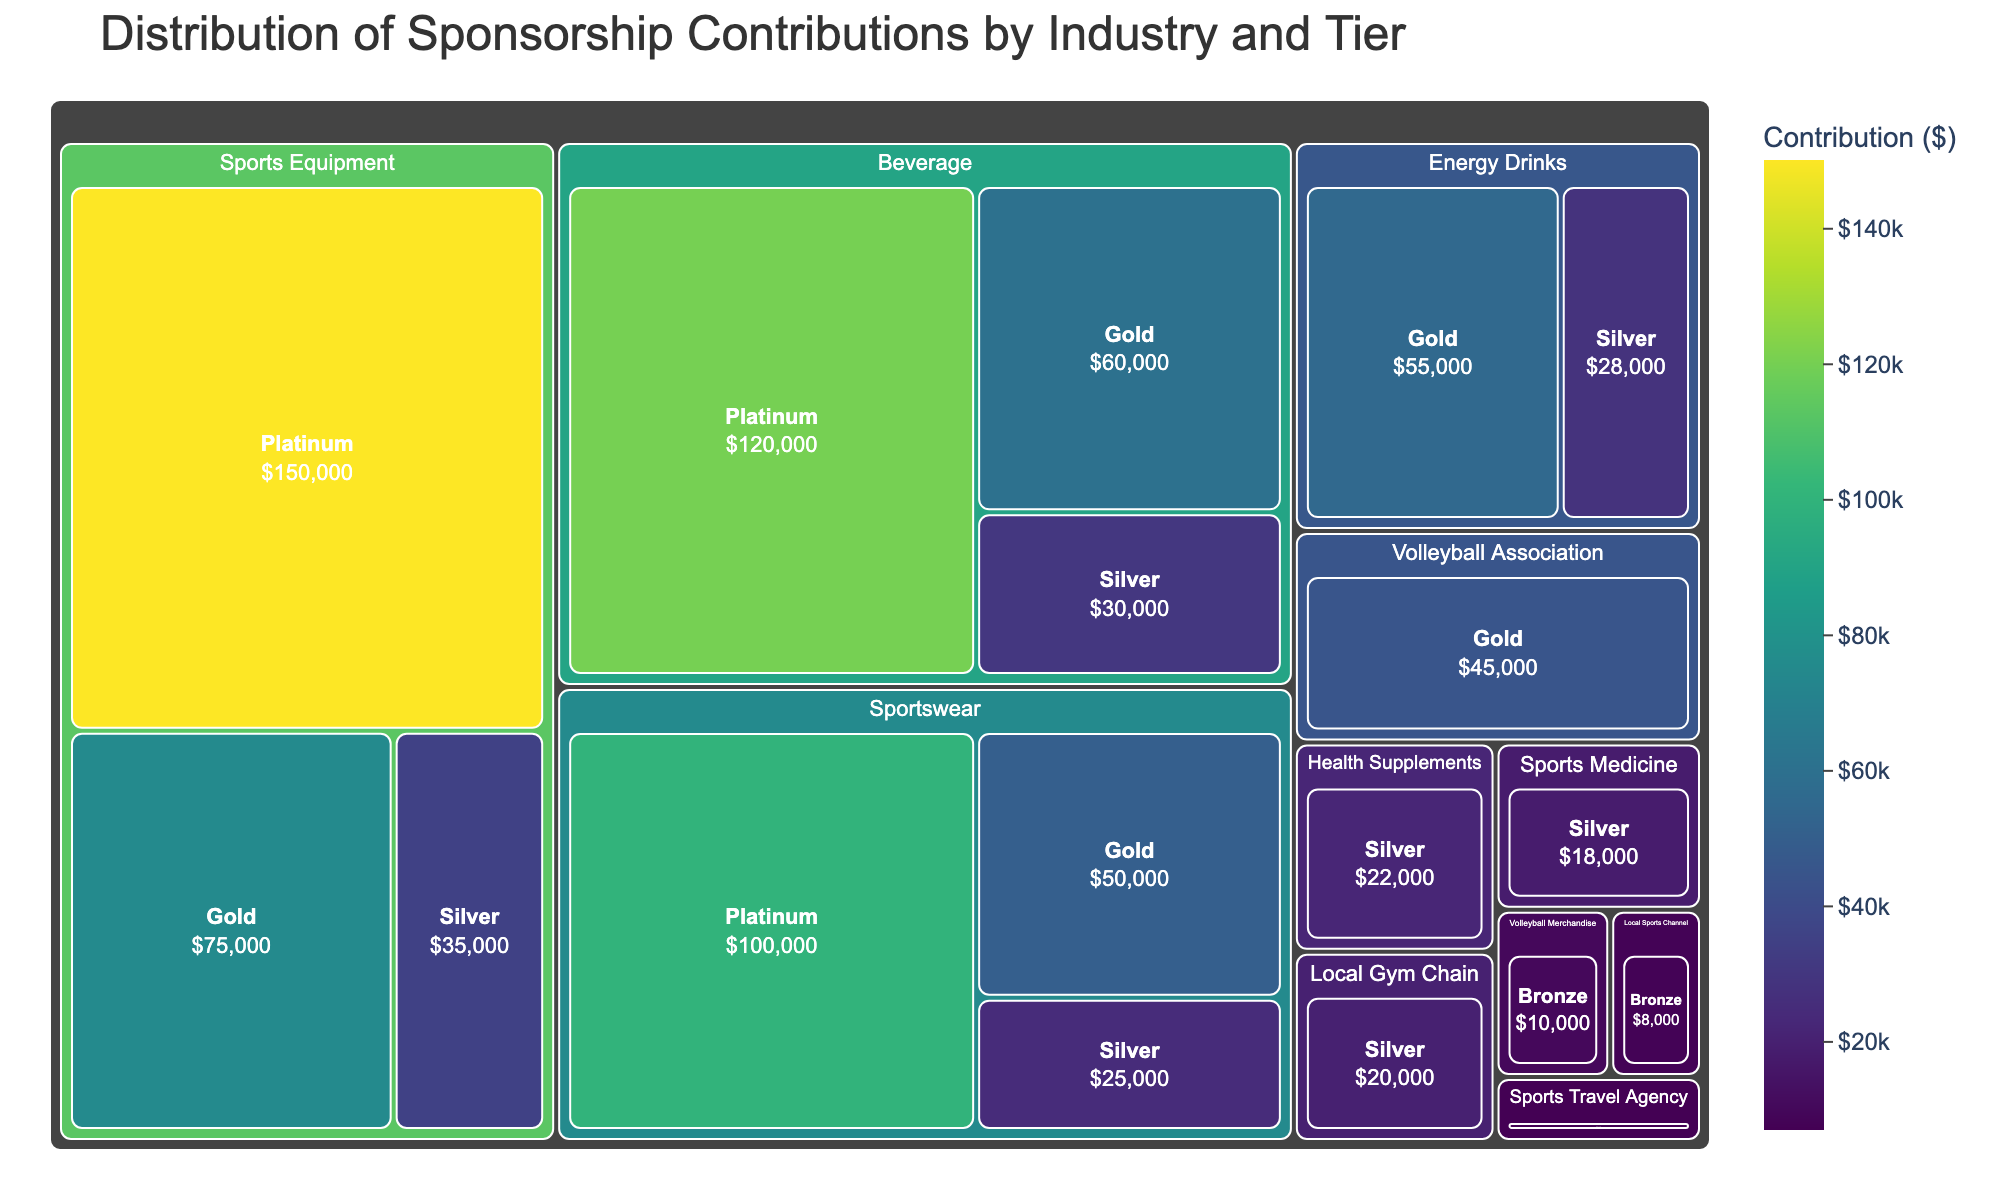What is the title of the treemap? The title is found at the top of the treemap in large font. It summarizes the main content and purpose of the plot.
Answer: Distribution of Sponsorship Contributions by Industry and Tier Which industry sector has the highest contribution at the Platinum tier? Locate the Platinum-tier segments first, then see which has the largest relative size and possibly the highest contribution color shading.
Answer: Sports Equipment What is the combined contribution of the Beverage sector in all tiers? Identify and sum the contributions of the Beverage sector at all tiers ($120,000 from Platinum, $60,000 from Gold, and $30,000 from Silver).
Answer: $210,000 How does the contribution of the Sportswear sector at the Gold tier compare to the Energy Drinks sector at the Gold tier? Locate the Gold-tier segments for both sectors and compare the values. Sportswear (Gold) has $50,000, and Energy Drinks (Gold) has $55,000.
Answer: Energy Drinks' contribution is higher What is the most significant contribution from any single tier within the Local Gym Chain sector? Locate the Local Gym Chain segment, which only has a Silver tier, and note its contribution.
Answer: $20,000 Which sponsorship tier shows the smallest individual contribution, and from which sector? Identify the smallest segment visually, then check its label which indicates both the sector and contribution.
Answer: Sports Travel Agency, Bronze, $7,000 What's the total contribution of all sectors at the Silver tier combined? Sum each Silver-tier segment's contribution across all sectors ($35,000 from Sports Equipment + $30,000 from Beverage + $25,000 from Sportswear + $28,000 from Energy Drinks + $20,000 from Local Gym Chain + $22,000 from Health Supplements + $18,000 from Sports Medicine).
Answer: $178,000 How many sectors are contributing at the Bronze tier, and what is their total contribution? Count all the distinct sector segments at the Bronze tier and sum their contributions. Sectors: Volleyball Merchandise, Local Sports Channel, Sports Travel Agency. Total contribution: $10,000 + $8,000 + $7,000.
Answer: 3 sectors, $25,000 What is the second highest contributing sector, and at what tiers are their contributions? Rank sectors by total contribution and find the second highest. The Beverage sector is second after Sports Equipment, with contributions at Platinum ($120,000), Gold ($60,000), and Silver ($30,000).
Answer: Beverage; Platinum, Gold, Silver 